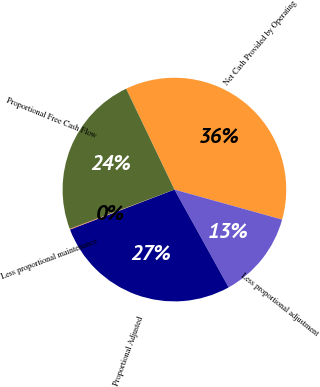Convert chart to OTSL. <chart><loc_0><loc_0><loc_500><loc_500><pie_chart><fcel>Net Cash Provided by Operating<fcel>Less proportional adjustment<fcel>Proportional Adjusted<fcel>Less proportional maintenance<fcel>Proportional Free Cash Flow<nl><fcel>36.44%<fcel>12.62%<fcel>27.24%<fcel>0.11%<fcel>23.6%<nl></chart> 